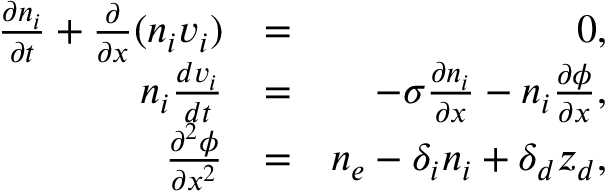<formula> <loc_0><loc_0><loc_500><loc_500>\begin{array} { r l r } { \frac { \partial n _ { i } } { \partial t } + \frac { \partial } { \partial x } ( n _ { i } v _ { i } ) } & { = } & { 0 , } \\ { n _ { i } \frac { d v _ { i } } { d t } } & { = } & { - \sigma \frac { \partial n _ { i } } { \partial x } - n _ { i } \frac { \partial \phi } { \partial x } , } \\ { \frac { \partial ^ { 2 } \phi } { \partial x ^ { 2 } } } & { = } & { n _ { e } - \delta _ { i } n _ { i } + \delta _ { d } z _ { d } , } \end{array}</formula> 